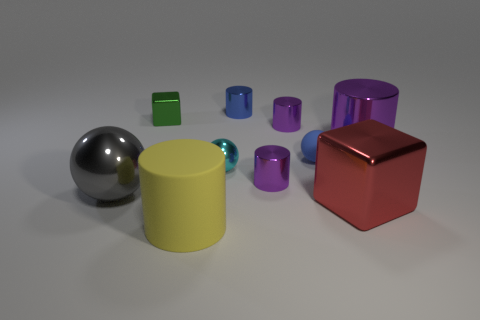How many purple cylinders must be subtracted to get 1 purple cylinders? 2 Subtract all small spheres. How many spheres are left? 1 Subtract all red cubes. How many cubes are left? 1 Subtract all blocks. How many objects are left? 8 Subtract 3 spheres. How many spheres are left? 0 Subtract 1 yellow cylinders. How many objects are left? 9 Subtract all cyan cubes. Subtract all blue cylinders. How many cubes are left? 2 Subtract all blue cylinders. How many blue balls are left? 1 Subtract all gray spheres. Subtract all big objects. How many objects are left? 5 Add 1 blue things. How many blue things are left? 3 